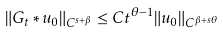Convert formula to latex. <formula><loc_0><loc_0><loc_500><loc_500>\| G _ { t } \ast u _ { 0 } \| _ { C ^ { s + \beta } } \leq C t ^ { \theta - 1 } \| u _ { 0 } \| _ { C ^ { \beta + s \theta } }</formula> 